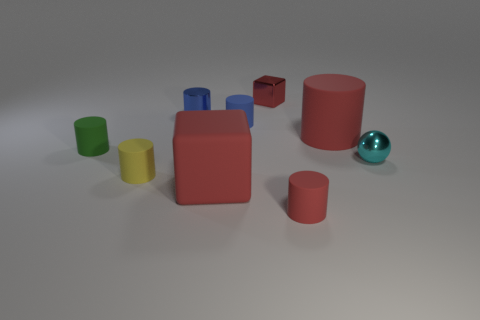Subtract all red blocks. How many were subtracted if there are1red blocks left? 1 Subtract all big rubber cylinders. How many cylinders are left? 5 Add 1 metal spheres. How many objects exist? 10 Subtract all green cylinders. How many cylinders are left? 5 Subtract all cubes. How many objects are left? 7 Subtract 2 blocks. How many blocks are left? 0 Subtract all green rubber things. Subtract all blocks. How many objects are left? 6 Add 2 small green cylinders. How many small green cylinders are left? 3 Add 3 large green cylinders. How many large green cylinders exist? 3 Subtract 0 brown cylinders. How many objects are left? 9 